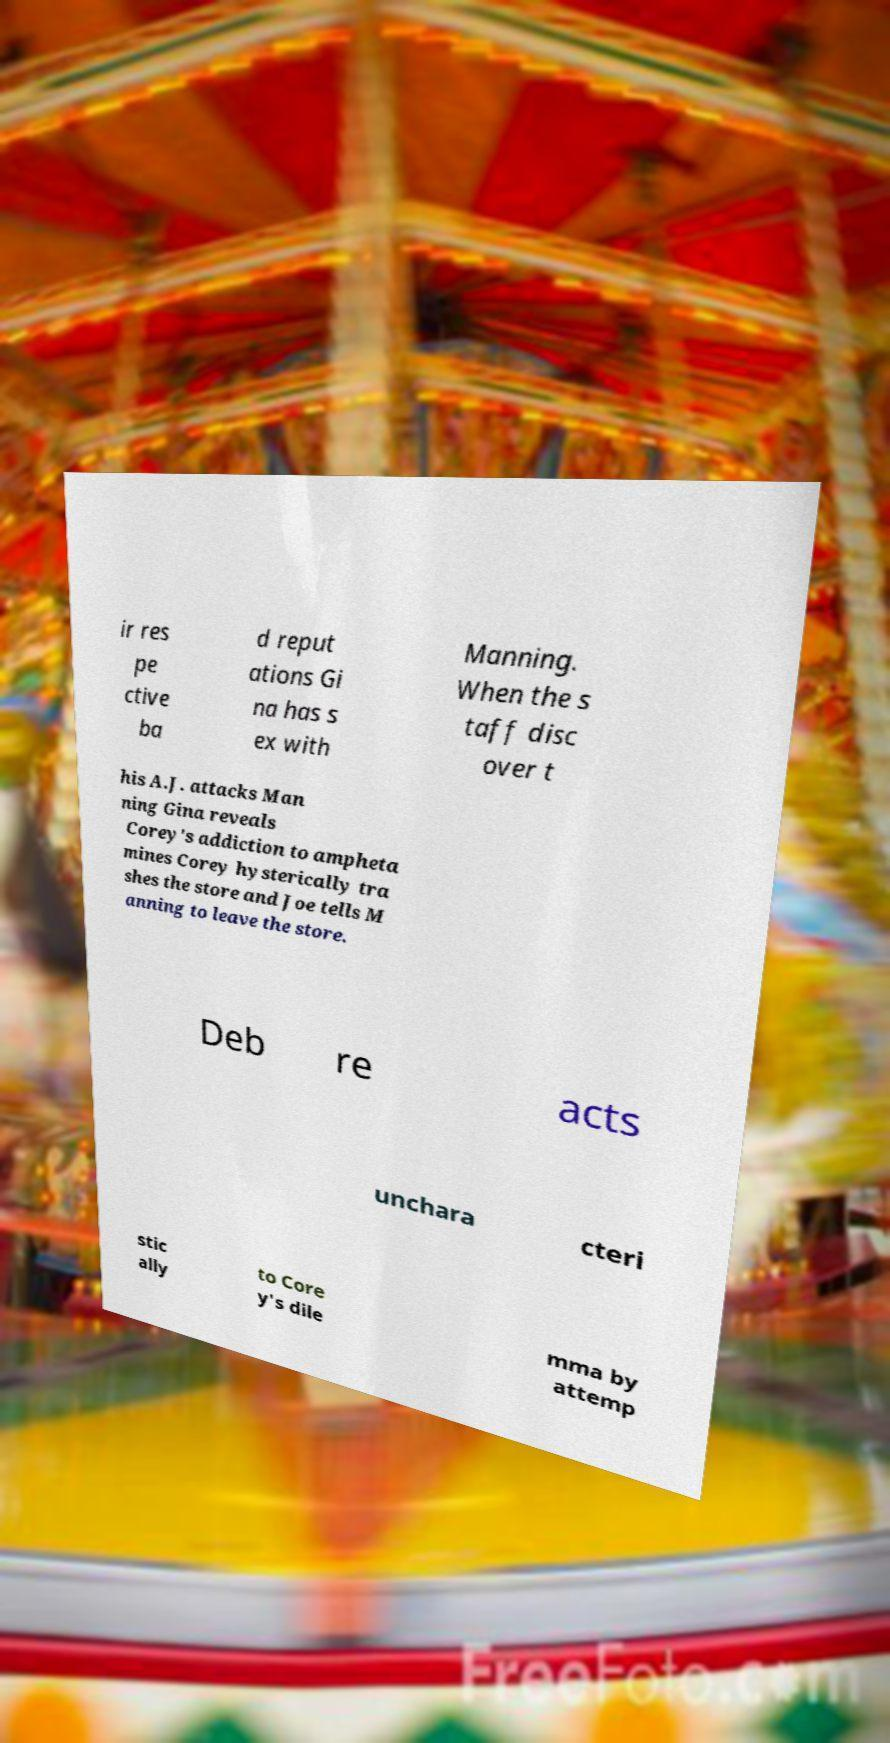There's text embedded in this image that I need extracted. Can you transcribe it verbatim? ir res pe ctive ba d reput ations Gi na has s ex with Manning. When the s taff disc over t his A.J. attacks Man ning Gina reveals Corey's addiction to ampheta mines Corey hysterically tra shes the store and Joe tells M anning to leave the store. Deb re acts unchara cteri stic ally to Core y's dile mma by attemp 